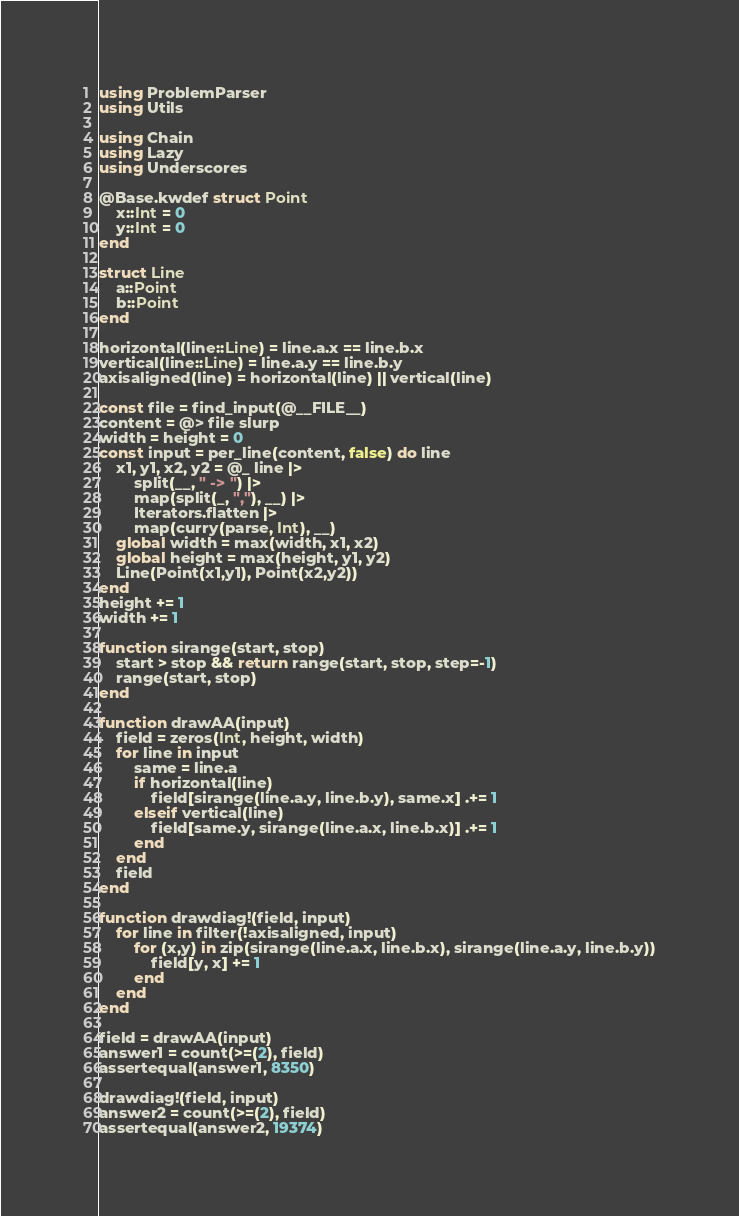Convert code to text. <code><loc_0><loc_0><loc_500><loc_500><_Julia_>using ProblemParser
using Utils

using Chain
using Lazy
using Underscores

@Base.kwdef struct Point
    x::Int = 0
    y::Int = 0
end

struct Line
    a::Point
    b::Point
end

horizontal(line::Line) = line.a.x == line.b.x
vertical(line::Line) = line.a.y == line.b.y
axisaligned(line) = horizontal(line) || vertical(line)

const file = find_input(@__FILE__)
content = @> file slurp
width = height = 0
const input = per_line(content, false) do line
    x1, y1, x2, y2 = @_ line |>
        split(__, " -> ") |>
        map(split(_, ","), __) |>
        Iterators.flatten |>
        map(curry(parse, Int), __)
    global width = max(width, x1, x2)
    global height = max(height, y1, y2)
    Line(Point(x1,y1), Point(x2,y2))
end
height += 1
width += 1

function sirange(start, stop)
    start > stop && return range(start, stop, step=-1)
    range(start, stop)
end

function drawAA(input)
    field = zeros(Int, height, width)
    for line in input
        same = line.a
        if horizontal(line)
            field[sirange(line.a.y, line.b.y), same.x] .+= 1
        elseif vertical(line)
            field[same.y, sirange(line.a.x, line.b.x)] .+= 1
        end
    end
    field
end

function drawdiag!(field, input)
    for line in filter(!axisaligned, input)
        for (x,y) in zip(sirange(line.a.x, line.b.x), sirange(line.a.y, line.b.y))
            field[y, x] += 1
        end
    end
end

field = drawAA(input)
answer1 = count(>=(2), field)
assertequal(answer1, 8350)

drawdiag!(field, input)
answer2 = count(>=(2), field)
assertequal(answer2, 19374)
</code> 